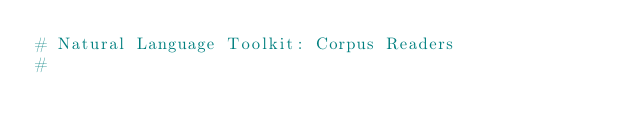Convert code to text. <code><loc_0><loc_0><loc_500><loc_500><_Python_># Natural Language Toolkit: Corpus Readers
#</code> 